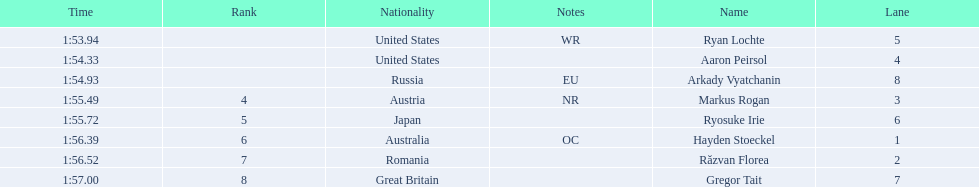Who are the swimmers? Ryan Lochte, Aaron Peirsol, Arkady Vyatchanin, Markus Rogan, Ryosuke Irie, Hayden Stoeckel, Răzvan Florea, Gregor Tait. What is ryosuke irie's time? 1:55.72. 